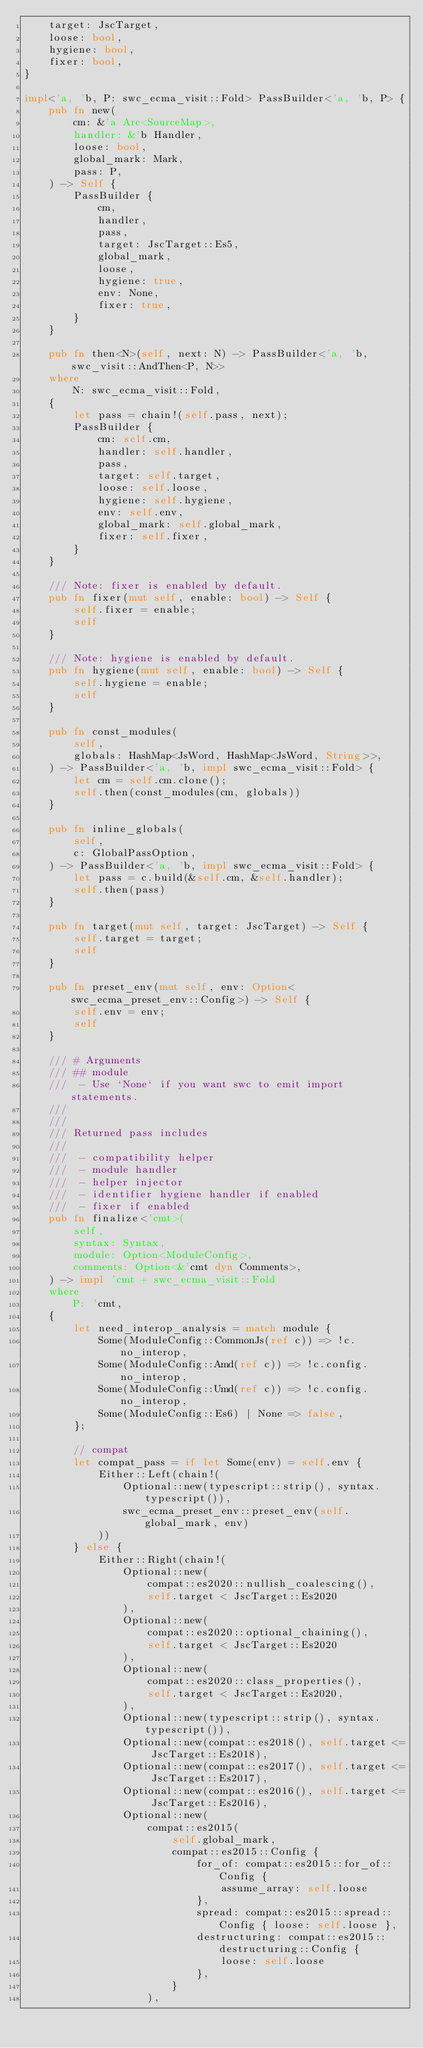<code> <loc_0><loc_0><loc_500><loc_500><_Rust_>    target: JscTarget,
    loose: bool,
    hygiene: bool,
    fixer: bool,
}

impl<'a, 'b, P: swc_ecma_visit::Fold> PassBuilder<'a, 'b, P> {
    pub fn new(
        cm: &'a Arc<SourceMap>,
        handler: &'b Handler,
        loose: bool,
        global_mark: Mark,
        pass: P,
    ) -> Self {
        PassBuilder {
            cm,
            handler,
            pass,
            target: JscTarget::Es5,
            global_mark,
            loose,
            hygiene: true,
            env: None,
            fixer: true,
        }
    }

    pub fn then<N>(self, next: N) -> PassBuilder<'a, 'b, swc_visit::AndThen<P, N>>
    where
        N: swc_ecma_visit::Fold,
    {
        let pass = chain!(self.pass, next);
        PassBuilder {
            cm: self.cm,
            handler: self.handler,
            pass,
            target: self.target,
            loose: self.loose,
            hygiene: self.hygiene,
            env: self.env,
            global_mark: self.global_mark,
            fixer: self.fixer,
        }
    }

    /// Note: fixer is enabled by default.
    pub fn fixer(mut self, enable: bool) -> Self {
        self.fixer = enable;
        self
    }

    /// Note: hygiene is enabled by default.
    pub fn hygiene(mut self, enable: bool) -> Self {
        self.hygiene = enable;
        self
    }

    pub fn const_modules(
        self,
        globals: HashMap<JsWord, HashMap<JsWord, String>>,
    ) -> PassBuilder<'a, 'b, impl swc_ecma_visit::Fold> {
        let cm = self.cm.clone();
        self.then(const_modules(cm, globals))
    }

    pub fn inline_globals(
        self,
        c: GlobalPassOption,
    ) -> PassBuilder<'a, 'b, impl swc_ecma_visit::Fold> {
        let pass = c.build(&self.cm, &self.handler);
        self.then(pass)
    }

    pub fn target(mut self, target: JscTarget) -> Self {
        self.target = target;
        self
    }

    pub fn preset_env(mut self, env: Option<swc_ecma_preset_env::Config>) -> Self {
        self.env = env;
        self
    }

    /// # Arguments
    /// ## module
    ///  - Use `None` if you want swc to emit import statements.
    ///
    ///
    /// Returned pass includes
    ///
    ///  - compatibility helper
    ///  - module handler
    ///  - helper injector
    ///  - identifier hygiene handler if enabled
    ///  - fixer if enabled
    pub fn finalize<'cmt>(
        self,
        syntax: Syntax,
        module: Option<ModuleConfig>,
        comments: Option<&'cmt dyn Comments>,
    ) -> impl 'cmt + swc_ecma_visit::Fold
    where
        P: 'cmt,
    {
        let need_interop_analysis = match module {
            Some(ModuleConfig::CommonJs(ref c)) => !c.no_interop,
            Some(ModuleConfig::Amd(ref c)) => !c.config.no_interop,
            Some(ModuleConfig::Umd(ref c)) => !c.config.no_interop,
            Some(ModuleConfig::Es6) | None => false,
        };

        // compat
        let compat_pass = if let Some(env) = self.env {
            Either::Left(chain!(
                Optional::new(typescript::strip(), syntax.typescript()),
                swc_ecma_preset_env::preset_env(self.global_mark, env)
            ))
        } else {
            Either::Right(chain!(
                Optional::new(
                    compat::es2020::nullish_coalescing(),
                    self.target < JscTarget::Es2020
                ),
                Optional::new(
                    compat::es2020::optional_chaining(),
                    self.target < JscTarget::Es2020
                ),
                Optional::new(
                    compat::es2020::class_properties(),
                    self.target < JscTarget::Es2020,
                ),
                Optional::new(typescript::strip(), syntax.typescript()),
                Optional::new(compat::es2018(), self.target <= JscTarget::Es2018),
                Optional::new(compat::es2017(), self.target <= JscTarget::Es2017),
                Optional::new(compat::es2016(), self.target <= JscTarget::Es2016),
                Optional::new(
                    compat::es2015(
                        self.global_mark,
                        compat::es2015::Config {
                            for_of: compat::es2015::for_of::Config {
                                assume_array: self.loose
                            },
                            spread: compat::es2015::spread::Config { loose: self.loose },
                            destructuring: compat::es2015::destructuring::Config {
                                loose: self.loose
                            },
                        }
                    ),</code> 